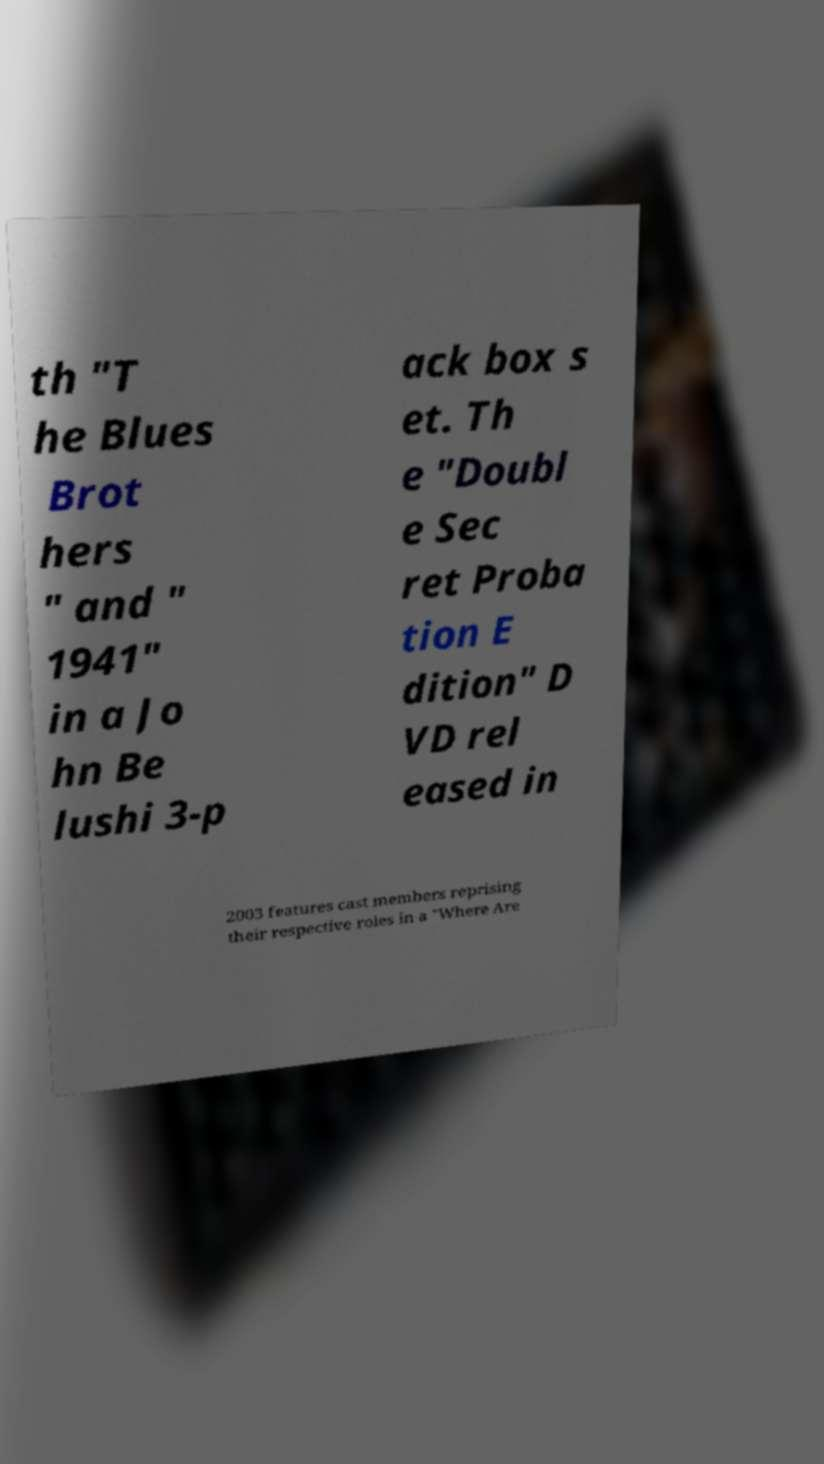What messages or text are displayed in this image? I need them in a readable, typed format. th "T he Blues Brot hers " and " 1941" in a Jo hn Be lushi 3-p ack box s et. Th e "Doubl e Sec ret Proba tion E dition" D VD rel eased in 2003 features cast members reprising their respective roles in a "Where Are 